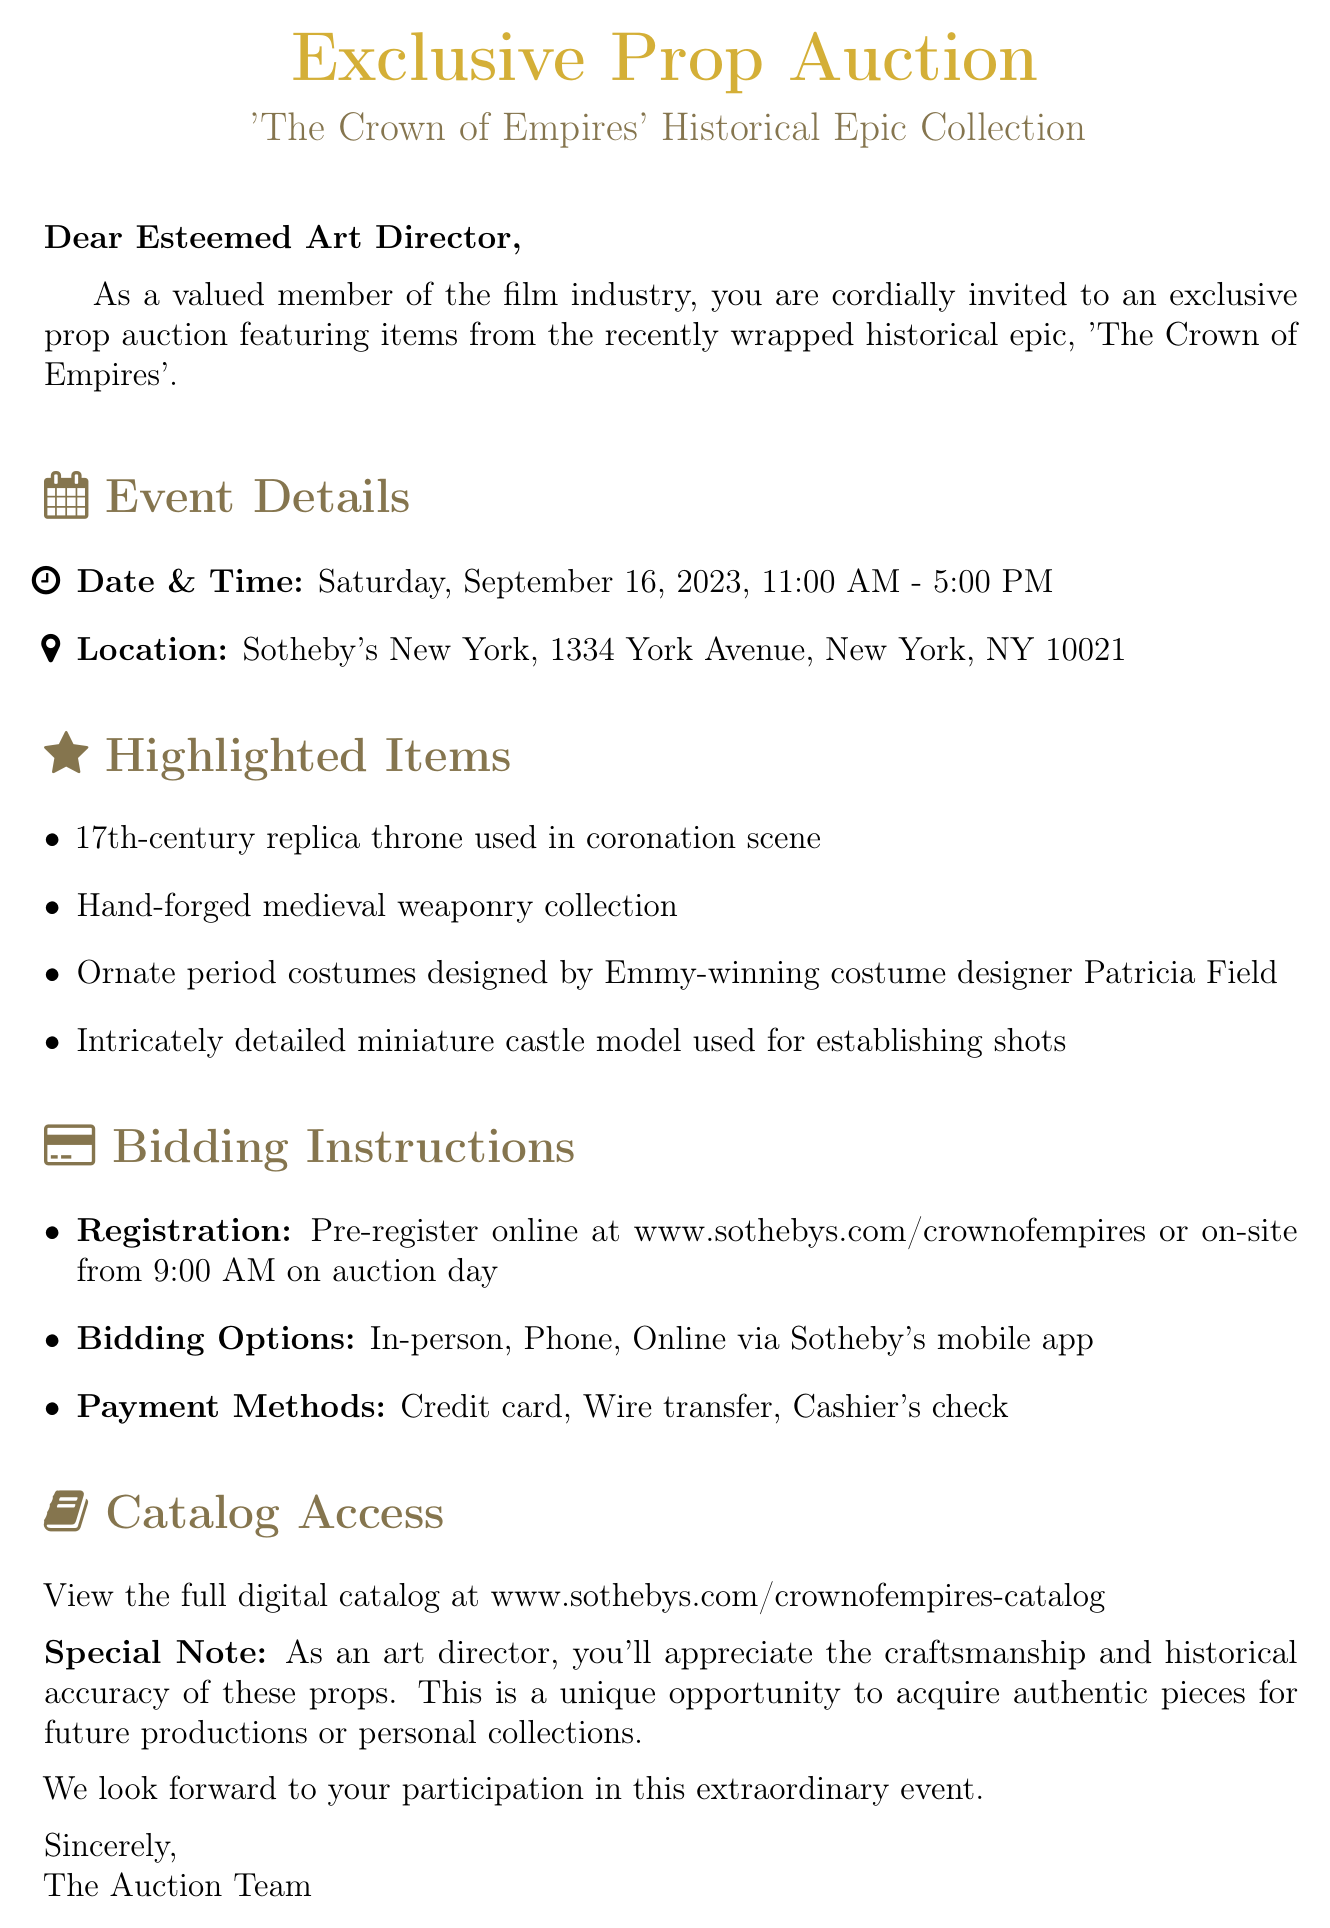What is the date of the auction? The date of the auction is mentioned specifically in the document under event details.
Answer: Saturday, September 16, 2023 What is the location of the auction? The location is clearly stated in the event details section of the document.
Answer: Sotheby's New York, 1334 York Avenue, New York, NY 10021 Which item is highlighted as a medieval weaponry collection? The highlighted items section features a hand-forged medieval weaponry collection specifically.
Answer: Hand-forged medieval weaponry collection What is the registration method for the auction? The document specifies the registration options included in the bidding instructions.
Answer: Pre-register online What time does the auction start? The starting time of the auction is specified in the event details.
Answer: 11:00 AM What is one of the payment methods accepted? The payment methods section lists several ways to make payments during the auction.
Answer: Credit card Which costume designer is mentioned in relation to the highlighted items? The highlighted items include costumes designed by an Emmy-winning designer, which is noted in the document.
Answer: Patricia Field How can participants access the full digital catalog? The document provides a link for catalog access, which is important for potential bidders.
Answer: www.sothebys.com/crownofempires-catalog What special note is included for art directors? A special note directed at art directors highlights the craftsmanship of the props, which is relevant to their interests.
Answer: You'll appreciate the craftsmanship and historical accuracy of these props 